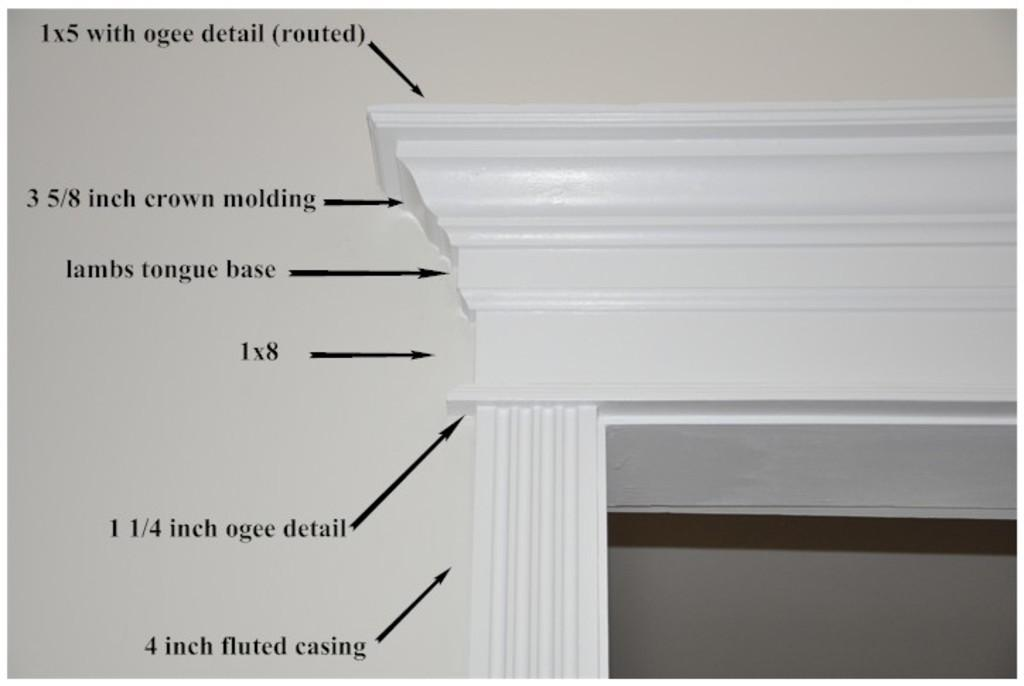What type of structure is visible in the image? There is a concrete structure in the image. Where can information about the structure be found in the image? Text describing the structure is located on the left side of the image. What is the texture of the look on the right side of the image? There is no mention of a "look" in the image, and the provided facts do not include any information about textures. 